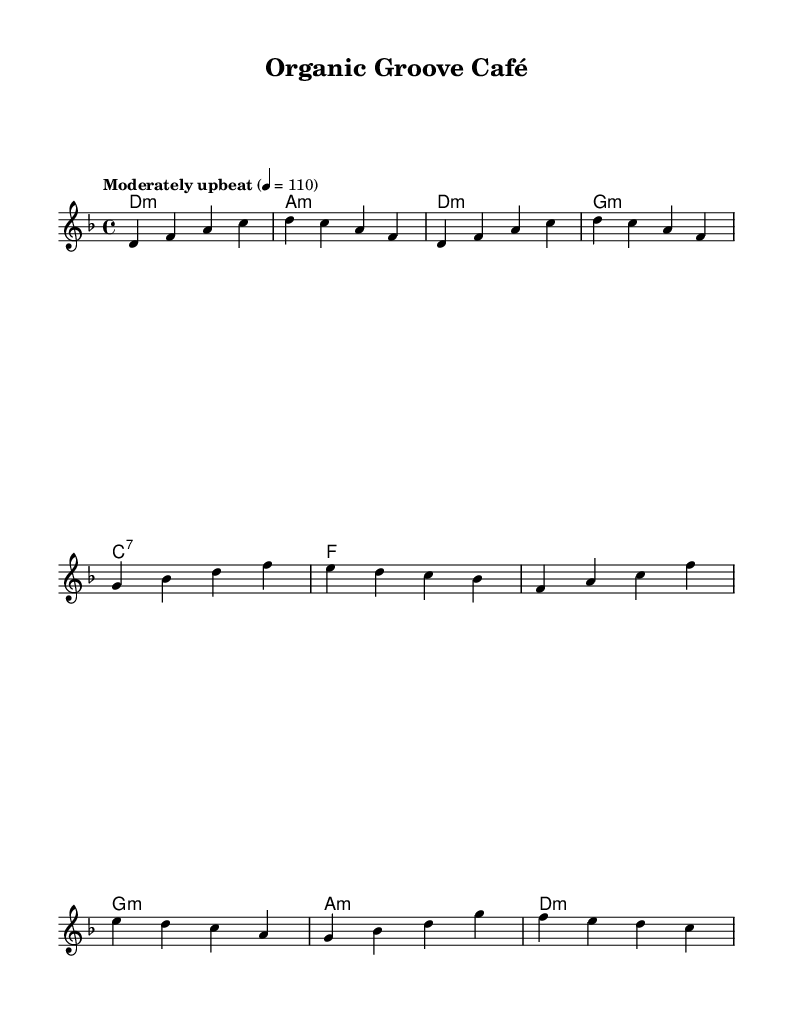What is the key signature of this music? The key signature is indicated at the beginning of the score, which shows two flats (B♭ and E♭), thus confirming the key of D minor.
Answer: D minor What is the time signature of this piece? The time signature, shown at the beginning of the score, is 4/4, meaning there are four beats in each measure, and the quarter note gets one beat.
Answer: 4/4 What is the tempo marking for this piece? The tempo marking indicates a "Moderately upbeat" speed of 110 beats per minute, which suggests a lively feel appropriate for a jazz-funk style.
Answer: Moderately upbeat, 110 What is the first chord in the introduction? The first chord in the introduction section is indicated as a D minor chord (d:m) in the chord names below the melody.
Answer: D minor How many measures are in the verse section? By counting the measures from the start of the verse to the end, there are eight measures in total, as shown by the notation.
Answer: Eight What is the final chord in the chorus? The last chord noted in the chorus is also a D minor chord, which wraps up the melodic phrase harmonically.
Answer: D minor What genre does this piece represent? The overall blend of acoustic and jazz-funk elements, along with its lively tempo and syncopated rhythms, categorizes it within the fusion genre, specifically inspired by organic cafes.
Answer: Fusion 